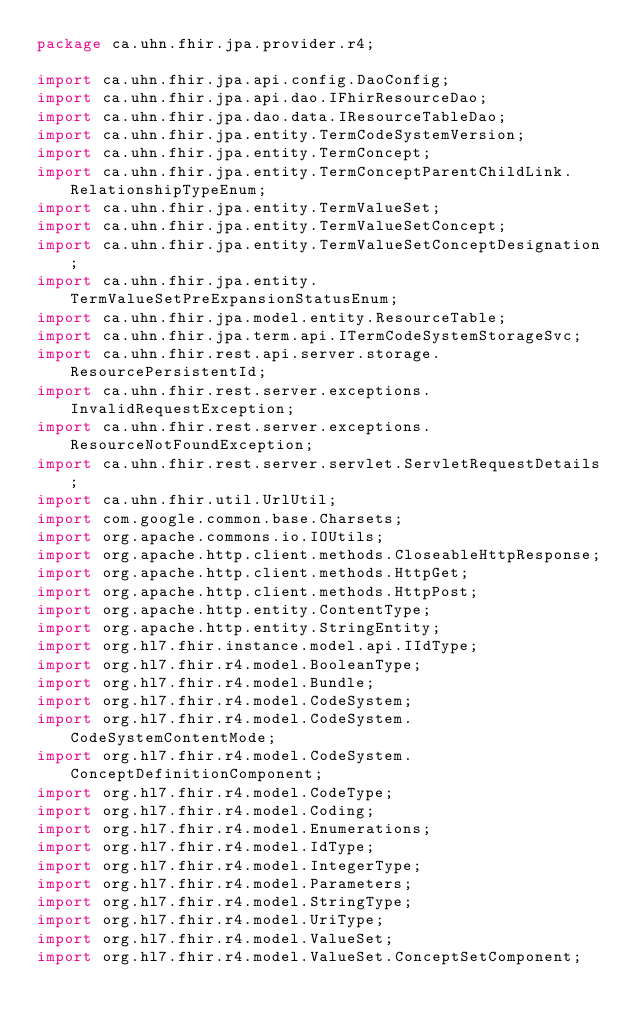Convert code to text. <code><loc_0><loc_0><loc_500><loc_500><_Java_>package ca.uhn.fhir.jpa.provider.r4;

import ca.uhn.fhir.jpa.api.config.DaoConfig;
import ca.uhn.fhir.jpa.api.dao.IFhirResourceDao;
import ca.uhn.fhir.jpa.dao.data.IResourceTableDao;
import ca.uhn.fhir.jpa.entity.TermCodeSystemVersion;
import ca.uhn.fhir.jpa.entity.TermConcept;
import ca.uhn.fhir.jpa.entity.TermConceptParentChildLink.RelationshipTypeEnum;
import ca.uhn.fhir.jpa.entity.TermValueSet;
import ca.uhn.fhir.jpa.entity.TermValueSetConcept;
import ca.uhn.fhir.jpa.entity.TermValueSetConceptDesignation;
import ca.uhn.fhir.jpa.entity.TermValueSetPreExpansionStatusEnum;
import ca.uhn.fhir.jpa.model.entity.ResourceTable;
import ca.uhn.fhir.jpa.term.api.ITermCodeSystemStorageSvc;
import ca.uhn.fhir.rest.api.server.storage.ResourcePersistentId;
import ca.uhn.fhir.rest.server.exceptions.InvalidRequestException;
import ca.uhn.fhir.rest.server.exceptions.ResourceNotFoundException;
import ca.uhn.fhir.rest.server.servlet.ServletRequestDetails;
import ca.uhn.fhir.util.UrlUtil;
import com.google.common.base.Charsets;
import org.apache.commons.io.IOUtils;
import org.apache.http.client.methods.CloseableHttpResponse;
import org.apache.http.client.methods.HttpGet;
import org.apache.http.client.methods.HttpPost;
import org.apache.http.entity.ContentType;
import org.apache.http.entity.StringEntity;
import org.hl7.fhir.instance.model.api.IIdType;
import org.hl7.fhir.r4.model.BooleanType;
import org.hl7.fhir.r4.model.Bundle;
import org.hl7.fhir.r4.model.CodeSystem;
import org.hl7.fhir.r4.model.CodeSystem.CodeSystemContentMode;
import org.hl7.fhir.r4.model.CodeSystem.ConceptDefinitionComponent;
import org.hl7.fhir.r4.model.CodeType;
import org.hl7.fhir.r4.model.Coding;
import org.hl7.fhir.r4.model.Enumerations;
import org.hl7.fhir.r4.model.IdType;
import org.hl7.fhir.r4.model.IntegerType;
import org.hl7.fhir.r4.model.Parameters;
import org.hl7.fhir.r4.model.StringType;
import org.hl7.fhir.r4.model.UriType;
import org.hl7.fhir.r4.model.ValueSet;
import org.hl7.fhir.r4.model.ValueSet.ConceptSetComponent;</code> 